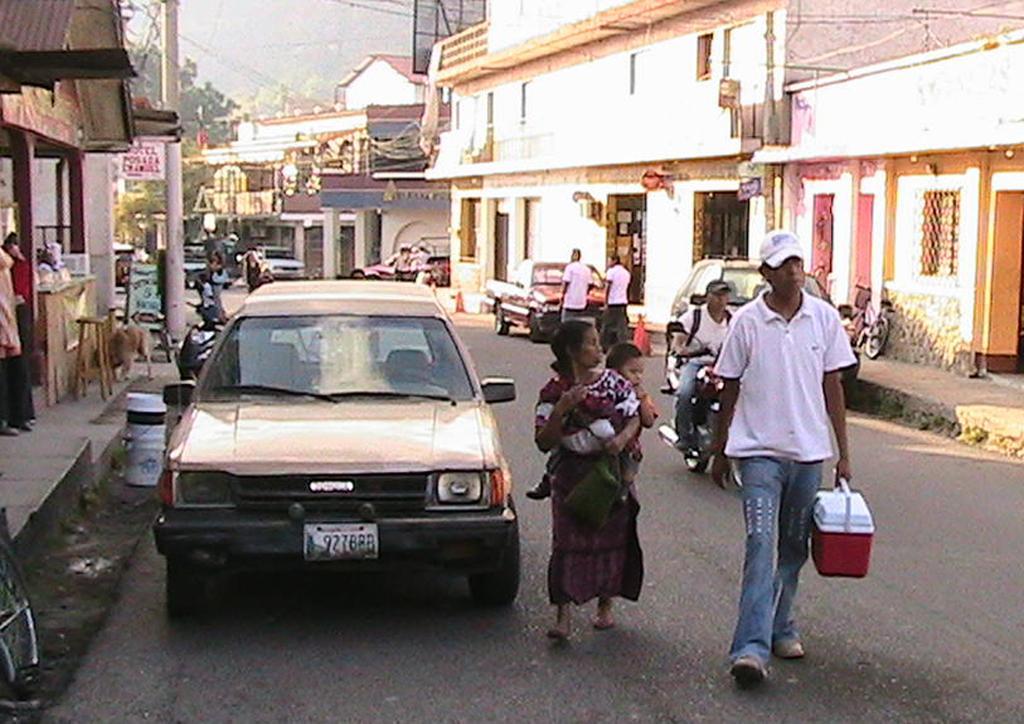Can you describe this image briefly? In the center of the image we can see a few vehicles, few people and one person is riding a bike on the road. Among them, we can see a few people are holding some objects. In the background, we can see the sky, buildings, few people and a few other objects. 